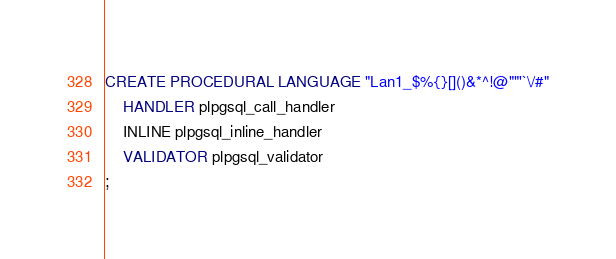<code> <loc_0><loc_0><loc_500><loc_500><_SQL_>CREATE PROCEDURAL LANGUAGE "Lan1_$%{}[]()&*^!@""'`\/#"
    HANDLER plpgsql_call_handler
    INLINE plpgsql_inline_handler
    VALIDATOR plpgsql_validator
;
</code> 